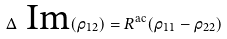<formula> <loc_0><loc_0><loc_500><loc_500>\Delta \text { Im} ( \rho _ { 1 2 } ) = R ^ { \text {ac} } ( \rho _ { 1 1 } - \rho _ { 2 2 } )</formula> 